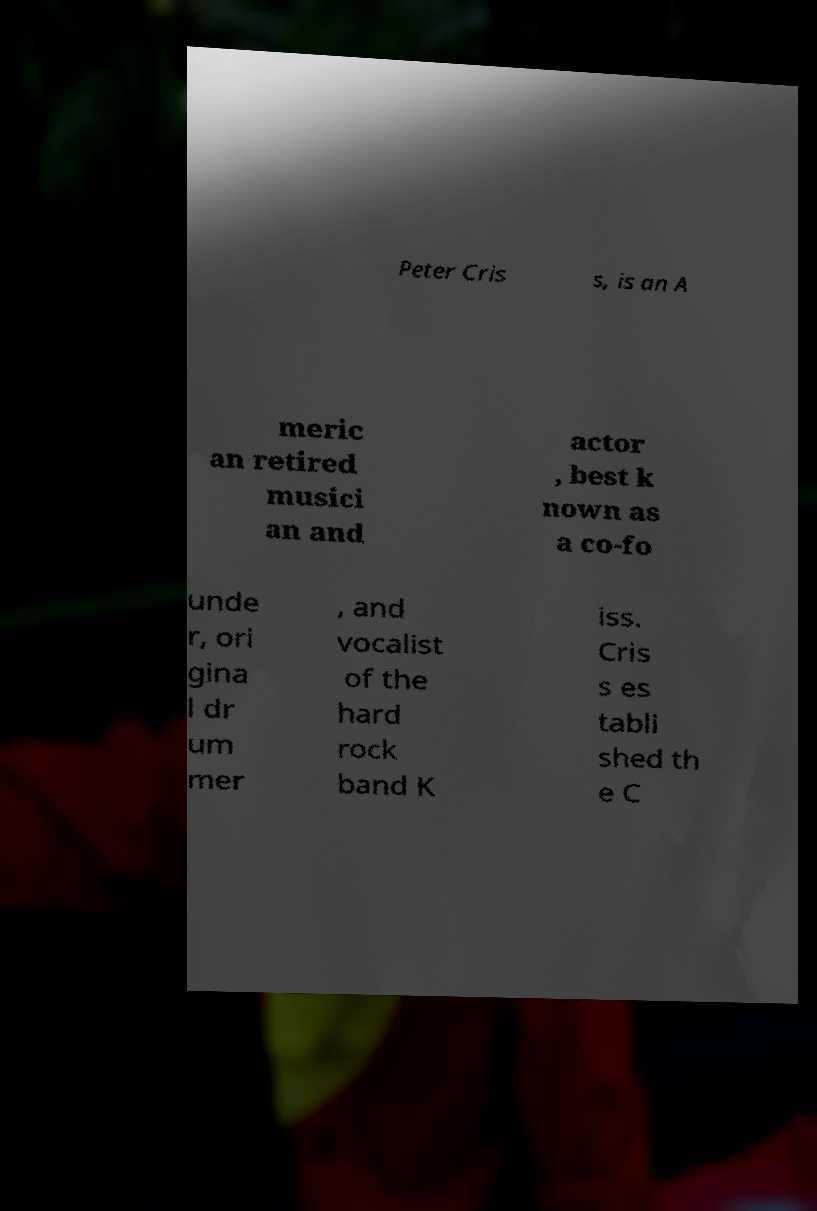Can you read and provide the text displayed in the image?This photo seems to have some interesting text. Can you extract and type it out for me? Peter Cris s, is an A meric an retired musici an and actor , best k nown as a co-fo unde r, ori gina l dr um mer , and vocalist of the hard rock band K iss. Cris s es tabli shed th e C 